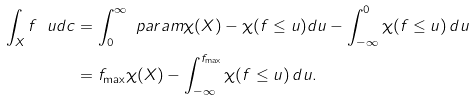<formula> <loc_0><loc_0><loc_500><loc_500>\int _ { X } f \ u d c & = \int _ { 0 } ^ { \infty } \ p a r a m { \chi ( X ) - \chi ( f \leq u ) } d u - \int _ { - \infty } ^ { 0 } \chi ( f \leq u ) \, d u \\ & = f _ { \max } \chi ( X ) - \int _ { - \infty } ^ { f _ { \max } } \chi ( f \leq u ) \, d u .</formula> 